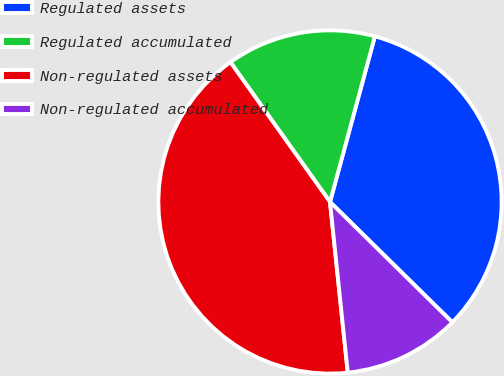Convert chart to OTSL. <chart><loc_0><loc_0><loc_500><loc_500><pie_chart><fcel>Regulated assets<fcel>Regulated accumulated<fcel>Non-regulated assets<fcel>Non-regulated accumulated<nl><fcel>33.16%<fcel>14.06%<fcel>41.8%<fcel>10.98%<nl></chart> 